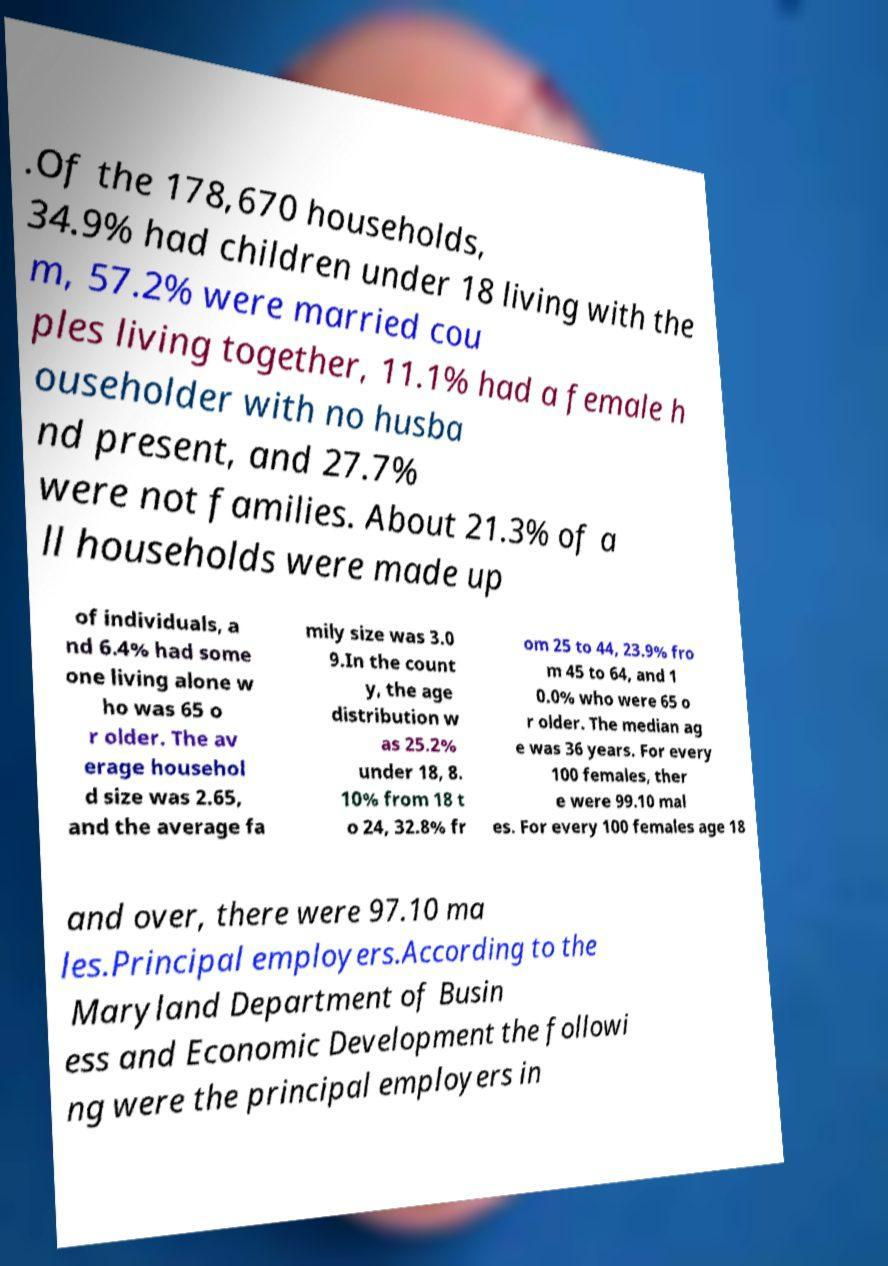Please read and relay the text visible in this image. What does it say? .Of the 178,670 households, 34.9% had children under 18 living with the m, 57.2% were married cou ples living together, 11.1% had a female h ouseholder with no husba nd present, and 27.7% were not families. About 21.3% of a ll households were made up of individuals, a nd 6.4% had some one living alone w ho was 65 o r older. The av erage househol d size was 2.65, and the average fa mily size was 3.0 9.In the count y, the age distribution w as 25.2% under 18, 8. 10% from 18 t o 24, 32.8% fr om 25 to 44, 23.9% fro m 45 to 64, and 1 0.0% who were 65 o r older. The median ag e was 36 years. For every 100 females, ther e were 99.10 mal es. For every 100 females age 18 and over, there were 97.10 ma les.Principal employers.According to the Maryland Department of Busin ess and Economic Development the followi ng were the principal employers in 